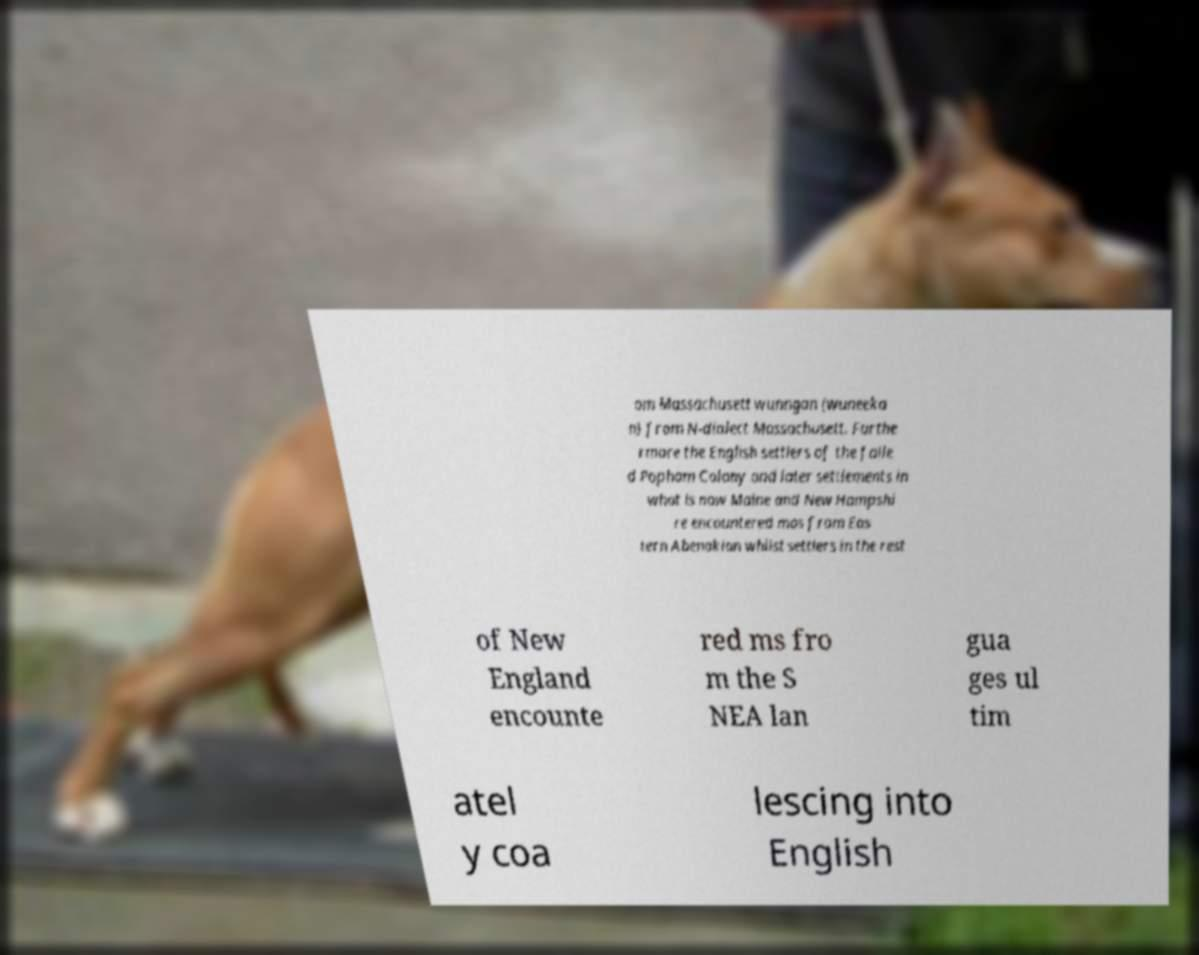Could you extract and type out the text from this image? om Massachusett wunngan (wuneeka n) from N-dialect Massachusett. Furthe rmore the English settlers of the faile d Popham Colony and later settlements in what is now Maine and New Hampshi re encountered mos from Eas tern Abenakian whilst settlers in the rest of New England encounte red ms fro m the S NEA lan gua ges ul tim atel y coa lescing into English 